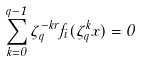<formula> <loc_0><loc_0><loc_500><loc_500>\sum _ { k = 0 } ^ { q - 1 } \zeta _ { q } ^ { - k r } f _ { i } ( \zeta _ { q } ^ { k } x ) = 0</formula> 